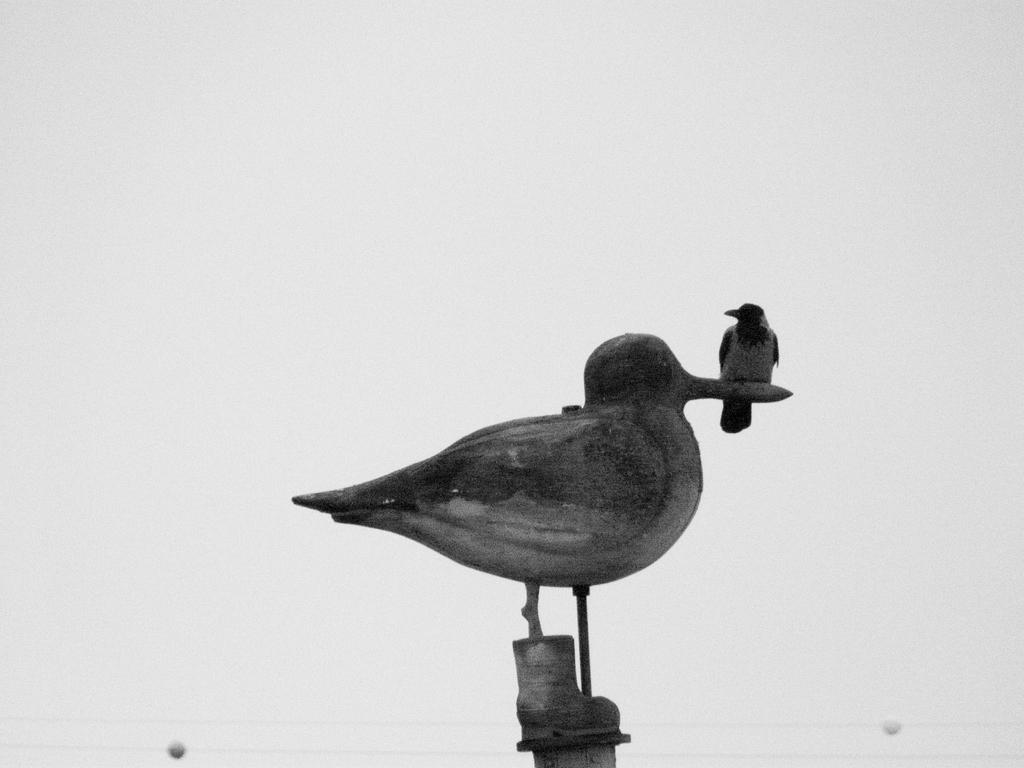What is the main subject in the center of the image? There is a sculpture in the center of the image. Is there anything on the sculpture? Yes, there is a crow on the sculpture. What type of behavior can be observed in the dirt around the sculpture? There is no dirt present in the image, and therefore no behavior can be observed in it. 